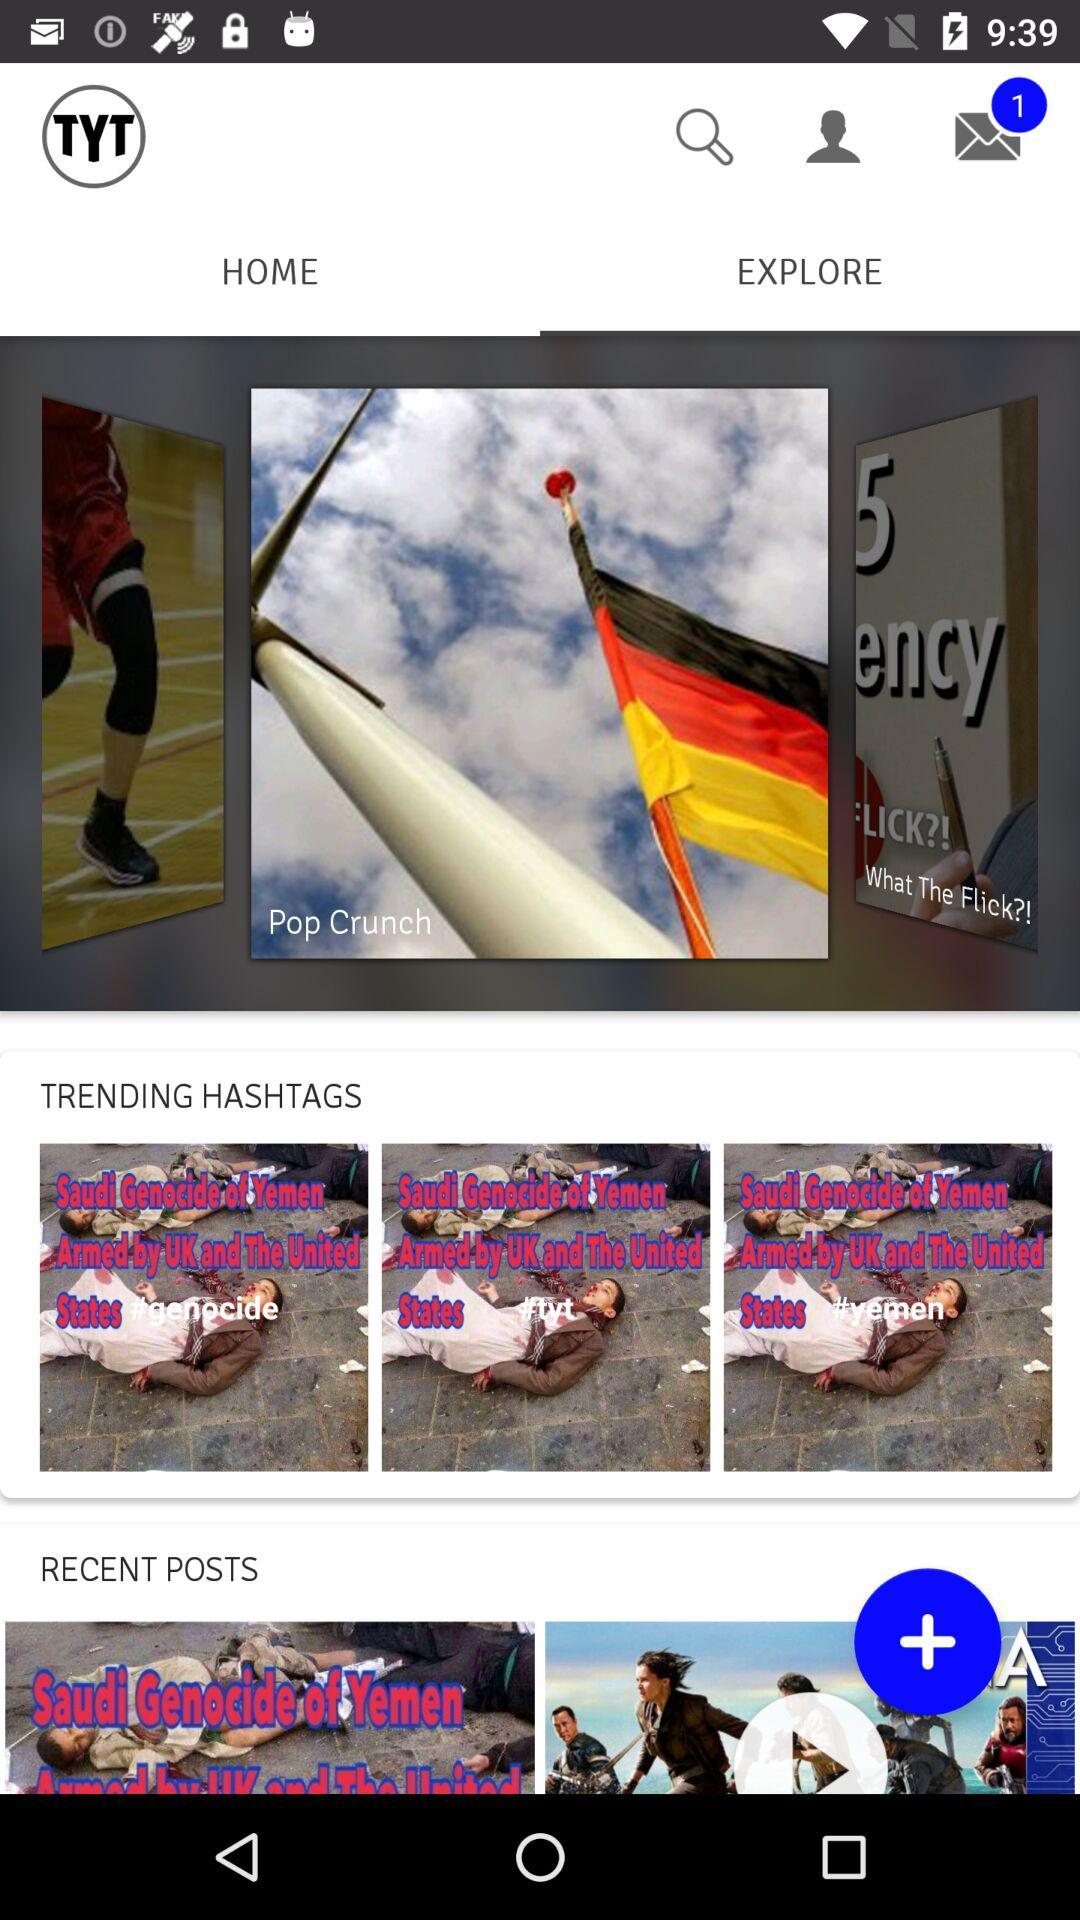How many messages are received? There is 1 received message. 